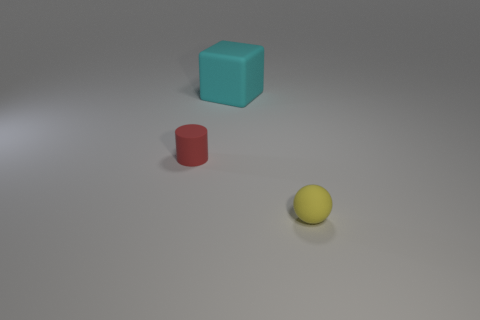Add 3 cyan rubber things. How many objects exist? 6 Subtract all cylinders. How many objects are left? 2 Add 2 tiny matte cylinders. How many tiny matte cylinders exist? 3 Subtract 0 gray cubes. How many objects are left? 3 Subtract all small blue matte cylinders. Subtract all small matte cylinders. How many objects are left? 2 Add 2 yellow rubber balls. How many yellow rubber balls are left? 3 